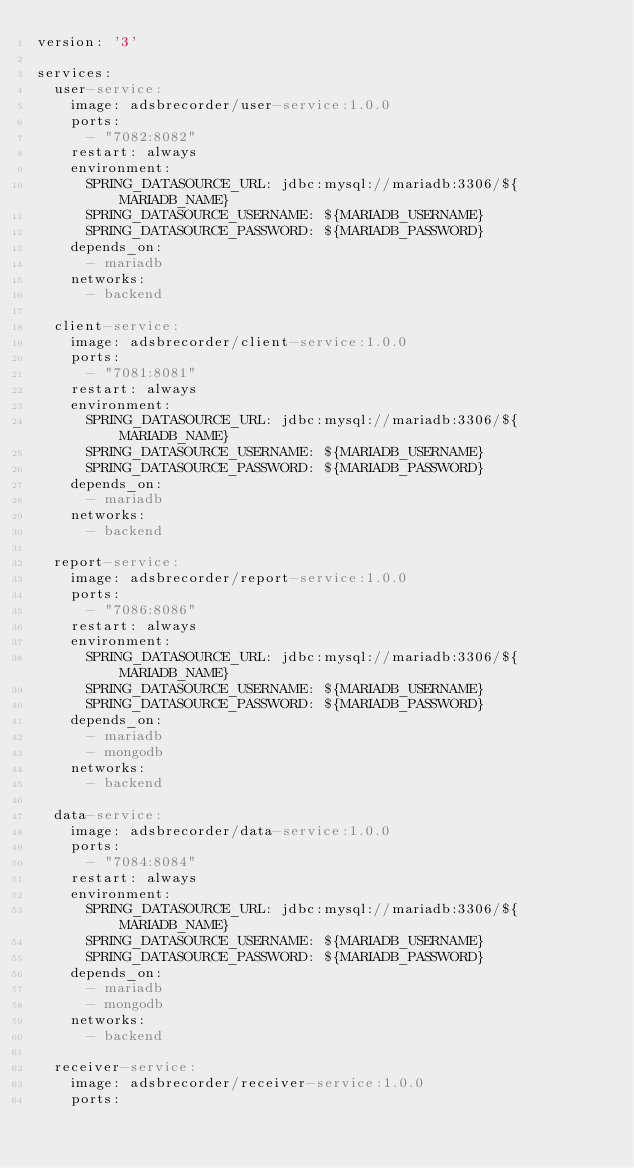Convert code to text. <code><loc_0><loc_0><loc_500><loc_500><_YAML_>version: '3'

services:
  user-service:
    image: adsbrecorder/user-service:1.0.0
    ports:
      - "7082:8082"
    restart: always
    environment:
      SPRING_DATASOURCE_URL: jdbc:mysql://mariadb:3306/${MARIADB_NAME}
      SPRING_DATASOURCE_USERNAME: ${MARIADB_USERNAME}
      SPRING_DATASOURCE_PASSWORD: ${MARIADB_PASSWORD}
    depends_on:
      - mariadb
    networks:
      - backend

  client-service:
    image: adsbrecorder/client-service:1.0.0
    ports:
      - "7081:8081"
    restart: always
    environment:
      SPRING_DATASOURCE_URL: jdbc:mysql://mariadb:3306/${MARIADB_NAME}
      SPRING_DATASOURCE_USERNAME: ${MARIADB_USERNAME}
      SPRING_DATASOURCE_PASSWORD: ${MARIADB_PASSWORD}
    depends_on:
      - mariadb
    networks:
      - backend

  report-service:
    image: adsbrecorder/report-service:1.0.0
    ports:
      - "7086:8086"
    restart: always
    environment:
      SPRING_DATASOURCE_URL: jdbc:mysql://mariadb:3306/${MARIADB_NAME}
      SPRING_DATASOURCE_USERNAME: ${MARIADB_USERNAME}
      SPRING_DATASOURCE_PASSWORD: ${MARIADB_PASSWORD}
    depends_on:
      - mariadb
      - mongodb
    networks:
      - backend

  data-service:
    image: adsbrecorder/data-service:1.0.0
    ports:
      - "7084:8084"
    restart: always
    environment:
      SPRING_DATASOURCE_URL: jdbc:mysql://mariadb:3306/${MARIADB_NAME}
      SPRING_DATASOURCE_USERNAME: ${MARIADB_USERNAME}
      SPRING_DATASOURCE_PASSWORD: ${MARIADB_PASSWORD}
    depends_on:
      - mariadb
      - mongodb
    networks:
      - backend

  receiver-service:
    image: adsbrecorder/receiver-service:1.0.0
    ports:</code> 